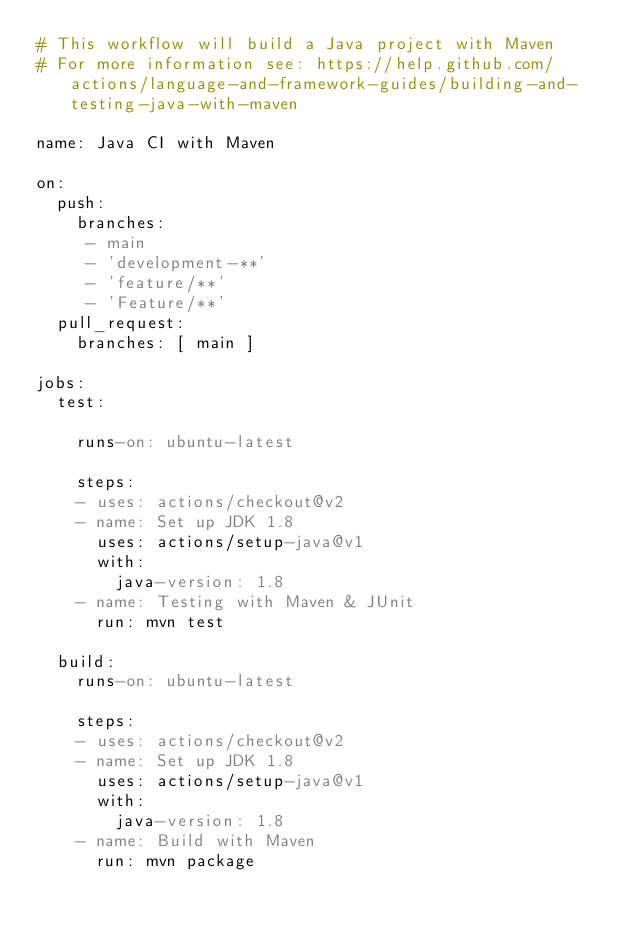<code> <loc_0><loc_0><loc_500><loc_500><_YAML_># This workflow will build a Java project with Maven
# For more information see: https://help.github.com/actions/language-and-framework-guides/building-and-testing-java-with-maven

name: Java CI with Maven

on:
  push:
    branches: 
     - main
     - 'development-**'
     - 'feature/**'
     - 'Feature/**'
  pull_request:
    branches: [ main ]

jobs:
  test:

    runs-on: ubuntu-latest

    steps:
    - uses: actions/checkout@v2
    - name: Set up JDK 1.8
      uses: actions/setup-java@v1
      with:
        java-version: 1.8
    - name: Testing with Maven & JUnit
      run: mvn test
      
  build:
    runs-on: ubuntu-latest

    steps:
    - uses: actions/checkout@v2
    - name: Set up JDK 1.8
      uses: actions/setup-java@v1
      with:
        java-version: 1.8
    - name: Build with Maven
      run: mvn package
</code> 